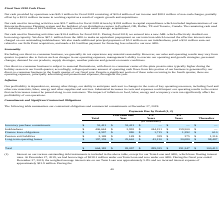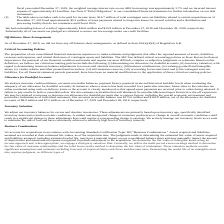According to Chefs Wharehouse's financial document, What is the total Inventory purchase commitments for all periods? According to the financial document, $53,413 (in thousands). The relevant text states: "Inventory purchase commitments $ 53,413 $ 53,413 $ — $ — $ —..." Also, What is the total Indebtedness for all periods? According to the financial document, $406,644 (in thousands). The relevant text states: "Indebtedness $ 406,644 $ 2,993 $ 244,151 $ 159,500 $ —..." Also, At December 27, 2019, what is the amount of borrowings under our Term Loan? According to the financial document, $238.1 million. The relevant text states: "rates. At December 27, 2019, we had borrowings of $238.1 million under our Term Loan and zero under our ABL. During the fiscal year ended December 27, 2019, the weig..." Also, can you calculate: What is the difference in the total Indebtedness and total Inventory purchase commitments for all periods? Based on the calculation: 406,644-53,413, the result is 353231 (in thousands). This is based on the information: "Inventory purchase commitments $ 53,413 $ 53,413 $ — $ — $ — Indebtedness $ 406,644 $ 2,993 $ 244,151 $ 159,500 $ —..." The key data points involved are: 406,644, 53,413. Also, can you calculate: What is the percentage constitution of total inventory purchase commitments among the total contractual obligations? Based on the calculation: 53,413/664,182, the result is 8.04 (percentage). This is based on the information: "Inventory purchase commitments $ 53,413 $ 53,413 $ — $ — $ — Total $ 664,182 $ 83,097 $ 289,325 $ 191,347 $ 100,413..." The key data points involved are: 53,413, 664,182. Additionally, Which component of contractual obligation has the highest total value? According to the financial document, Indebtedness. The relevant text states: "fective interest rates charged on our outstanding indebtedness. We also made additional principal payments of $5.2 million on our indebtedness, paid a $3.0 millio..." 